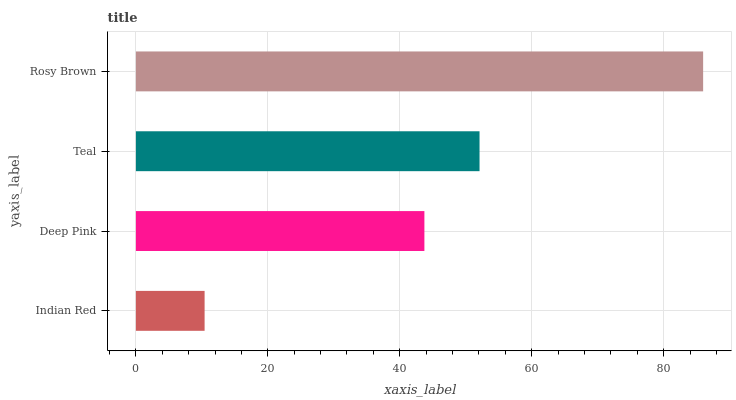Is Indian Red the minimum?
Answer yes or no. Yes. Is Rosy Brown the maximum?
Answer yes or no. Yes. Is Deep Pink the minimum?
Answer yes or no. No. Is Deep Pink the maximum?
Answer yes or no. No. Is Deep Pink greater than Indian Red?
Answer yes or no. Yes. Is Indian Red less than Deep Pink?
Answer yes or no. Yes. Is Indian Red greater than Deep Pink?
Answer yes or no. No. Is Deep Pink less than Indian Red?
Answer yes or no. No. Is Teal the high median?
Answer yes or no. Yes. Is Deep Pink the low median?
Answer yes or no. Yes. Is Deep Pink the high median?
Answer yes or no. No. Is Rosy Brown the low median?
Answer yes or no. No. 